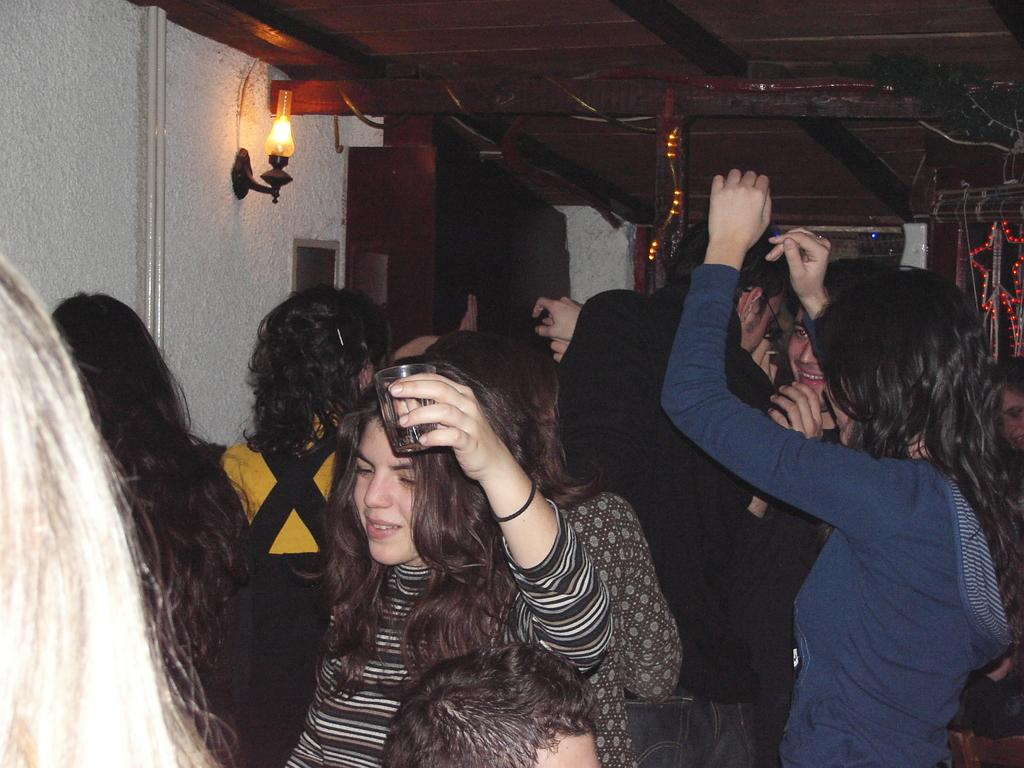Where might the image have been taken? The image might be taken inside a room. What are the people in the image doing? There is a group of people dancing in the image. Can you describe the lighting in the image? There is a light on the left side of the image. What can be seen on the left side of the image? There is a wall on the left side of the image. What is visible at the top of the image? The roof is visible at the top of the image. What is the taste of the dirt on the floor in the image? There is no dirt visible on the floor in the image, so it is not possible to determine its taste. 